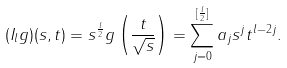<formula> <loc_0><loc_0><loc_500><loc_500>( I _ { l } g ) ( s , t ) = s ^ { \frac { l } { 2 } } g \left ( \frac { t } { \sqrt { s } } \right ) = \sum _ { j = 0 } ^ { [ \frac { l } { 2 } ] } a _ { j } s ^ { j } t ^ { l - 2 j } .</formula> 